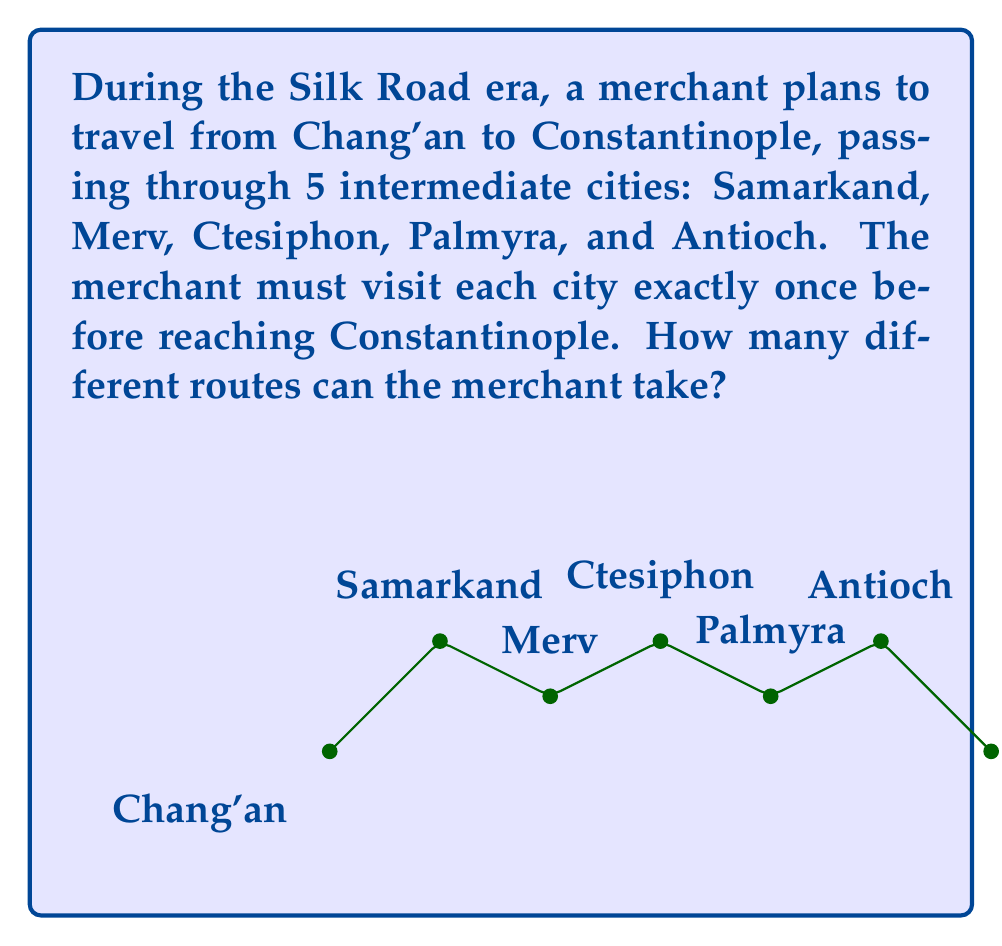Provide a solution to this math problem. Let's approach this step-by-step:

1) The merchant starts from Chang'an and ends at Constantinople. The order of visiting the 5 intermediate cities determines the route.

2) This is a permutation problem. We need to calculate how many ways we can arrange 5 cities.

3) The formula for permutations of n distinct objects is:

   $$P(n) = n!$$

   where $n!$ represents the factorial of $n$.

4) In this case, $n = 5$ (the number of intermediate cities).

5) Therefore, the number of possible routes is:

   $$P(5) = 5!$$

6) Let's calculate 5!:
   
   $$5! = 5 \times 4 \times 3 \times 2 \times 1 = 120$$

Thus, there are 120 different possible routes for the merchant to travel from Chang'an to Constantinople, visiting each intermediate city exactly once.
Answer: 120 